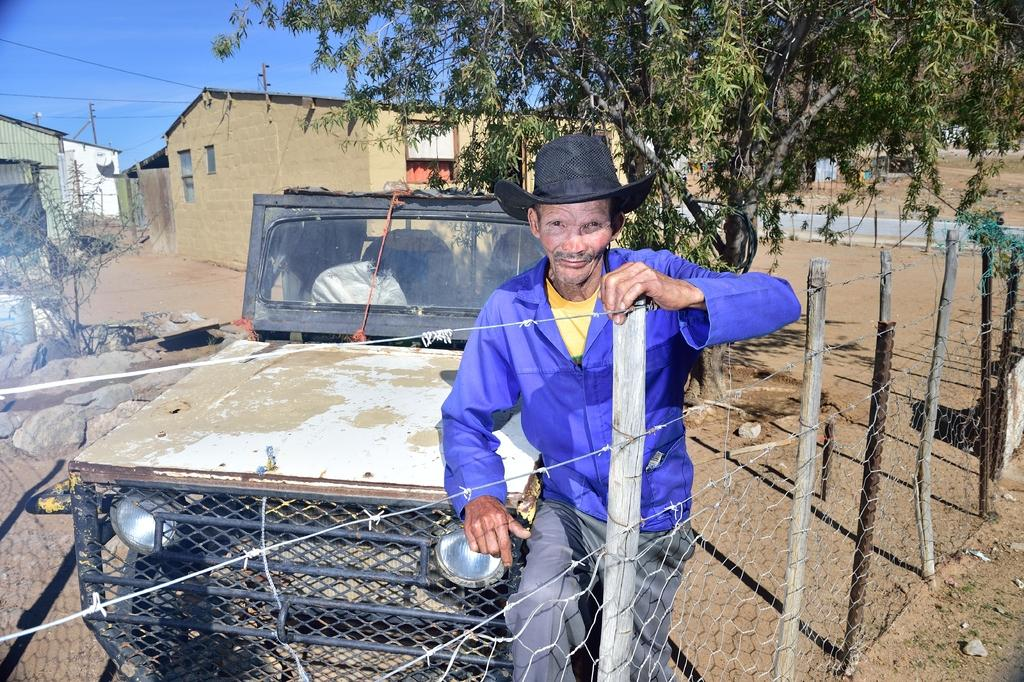Who is in the image? There is a person in the image. What is the person wearing? The person is wearing a violet dress. What is the person doing with their hands? The person has one hand on a fence and another hand on a vehicle. What can be seen in the background of the image? There are buildings and trees in the background of the image. What type of earthquake can be seen in the image? There is no earthquake present in the image. What town is visible in the background of the image? The image does not specify a town; it only shows buildings and trees in the background. 